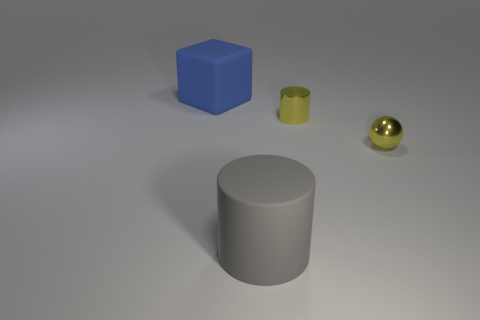Add 4 small metallic spheres. How many objects exist? 8 Add 1 blue rubber things. How many blue rubber things are left? 2 Add 1 tiny brown matte spheres. How many tiny brown matte spheres exist? 1 Subtract 0 gray cubes. How many objects are left? 4 Subtract all cubes. How many objects are left? 3 Subtract all big green objects. Subtract all blue rubber objects. How many objects are left? 3 